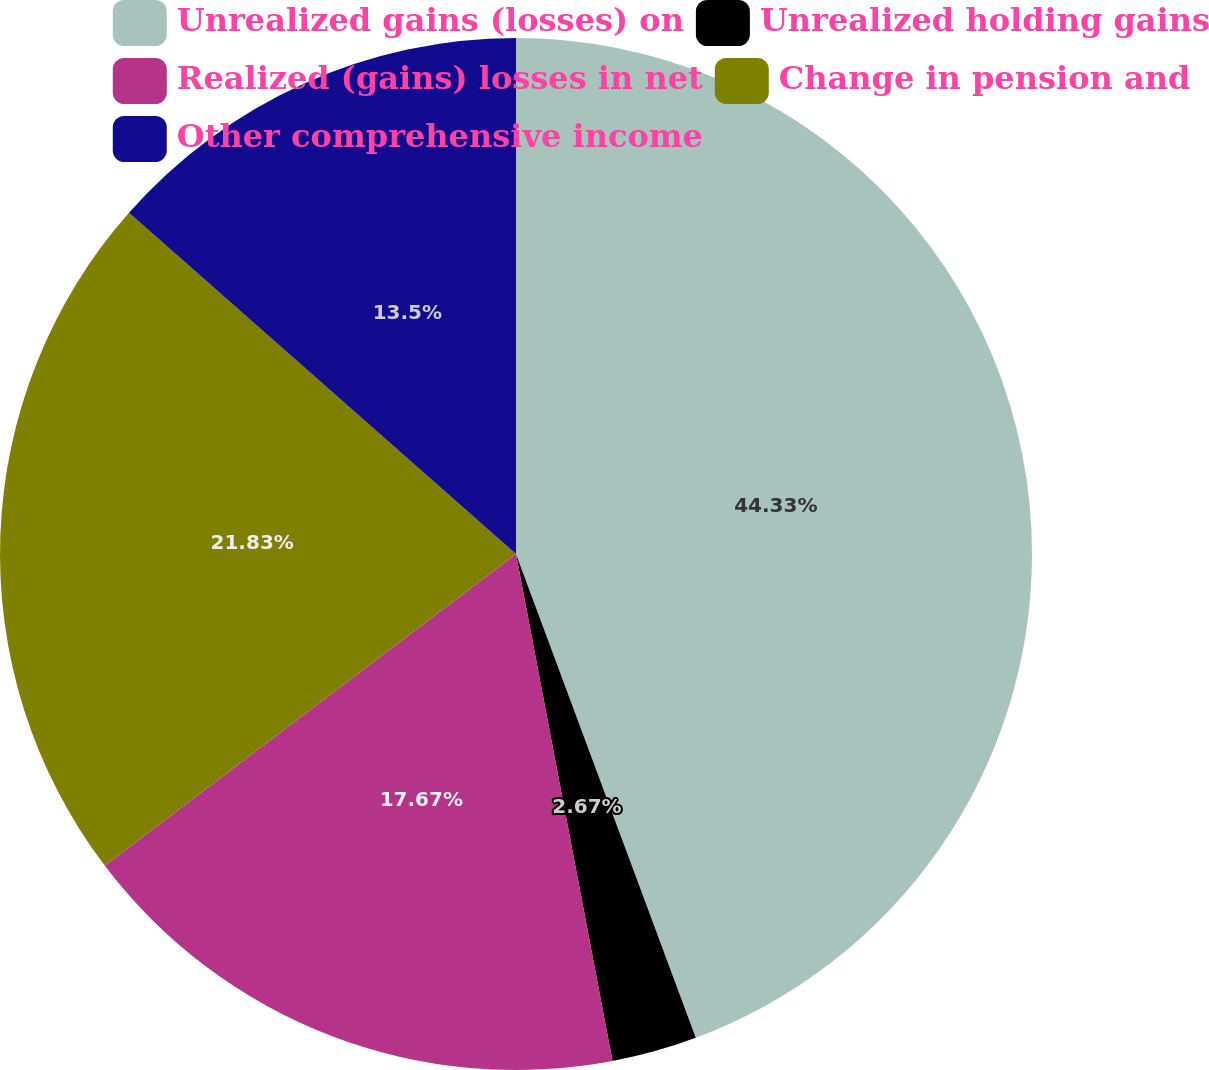Convert chart. <chart><loc_0><loc_0><loc_500><loc_500><pie_chart><fcel>Unrealized gains (losses) on<fcel>Unrealized holding gains<fcel>Realized (gains) losses in net<fcel>Change in pension and<fcel>Other comprehensive income<nl><fcel>44.34%<fcel>2.67%<fcel>17.67%<fcel>21.83%<fcel>13.5%<nl></chart> 